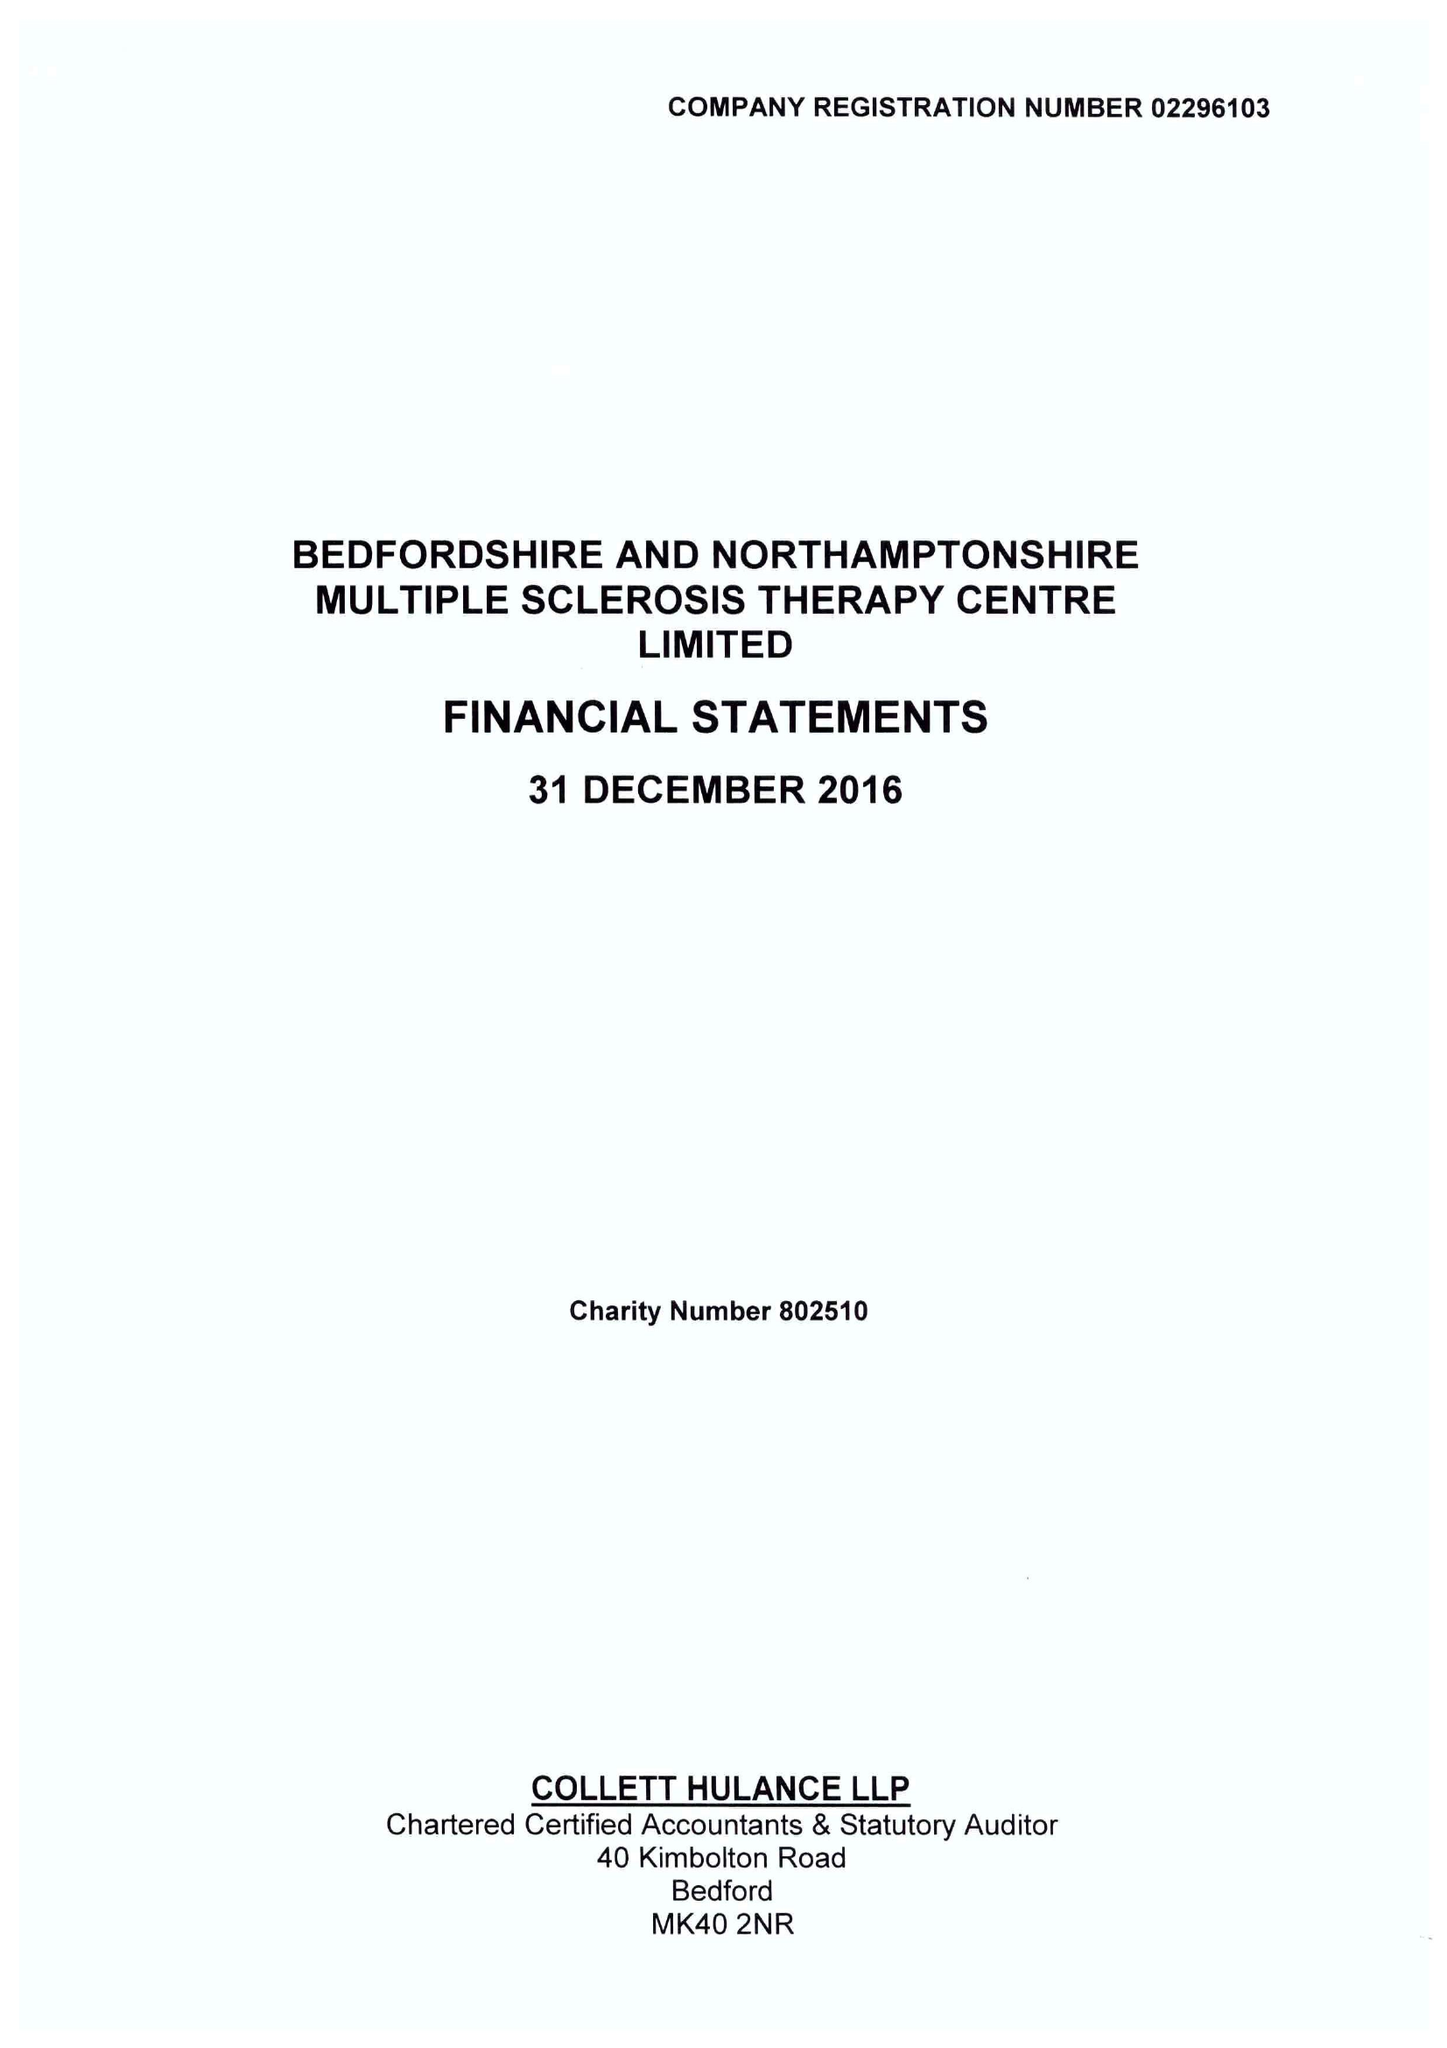What is the value for the report_date?
Answer the question using a single word or phrase. 2016-12-31 